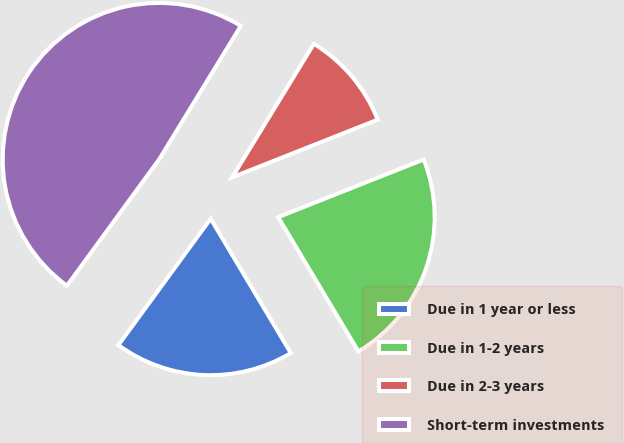Convert chart. <chart><loc_0><loc_0><loc_500><loc_500><pie_chart><fcel>Due in 1 year or less<fcel>Due in 1-2 years<fcel>Due in 2-3 years<fcel>Short-term investments<nl><fcel>18.6%<fcel>22.44%<fcel>10.26%<fcel>48.7%<nl></chart> 